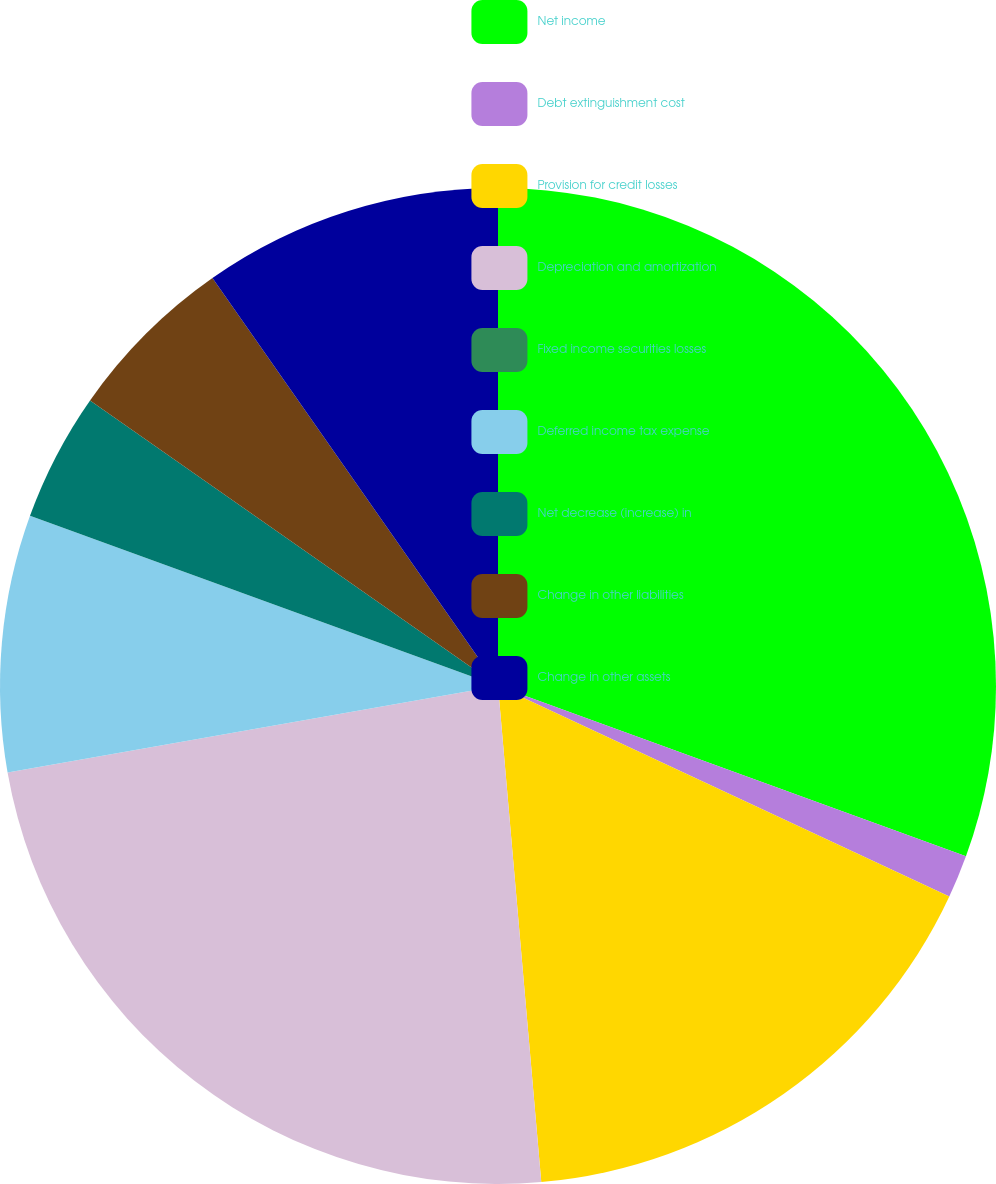Convert chart to OTSL. <chart><loc_0><loc_0><loc_500><loc_500><pie_chart><fcel>Net income<fcel>Debt extinguishment cost<fcel>Provision for credit losses<fcel>Depreciation and amortization<fcel>Fixed income securities losses<fcel>Deferred income tax expense<fcel>Net decrease (increase) in<fcel>Change in other liabilities<fcel>Change in other assets<nl><fcel>30.56%<fcel>1.39%<fcel>16.67%<fcel>23.61%<fcel>0.0%<fcel>8.33%<fcel>4.17%<fcel>5.56%<fcel>9.72%<nl></chart> 